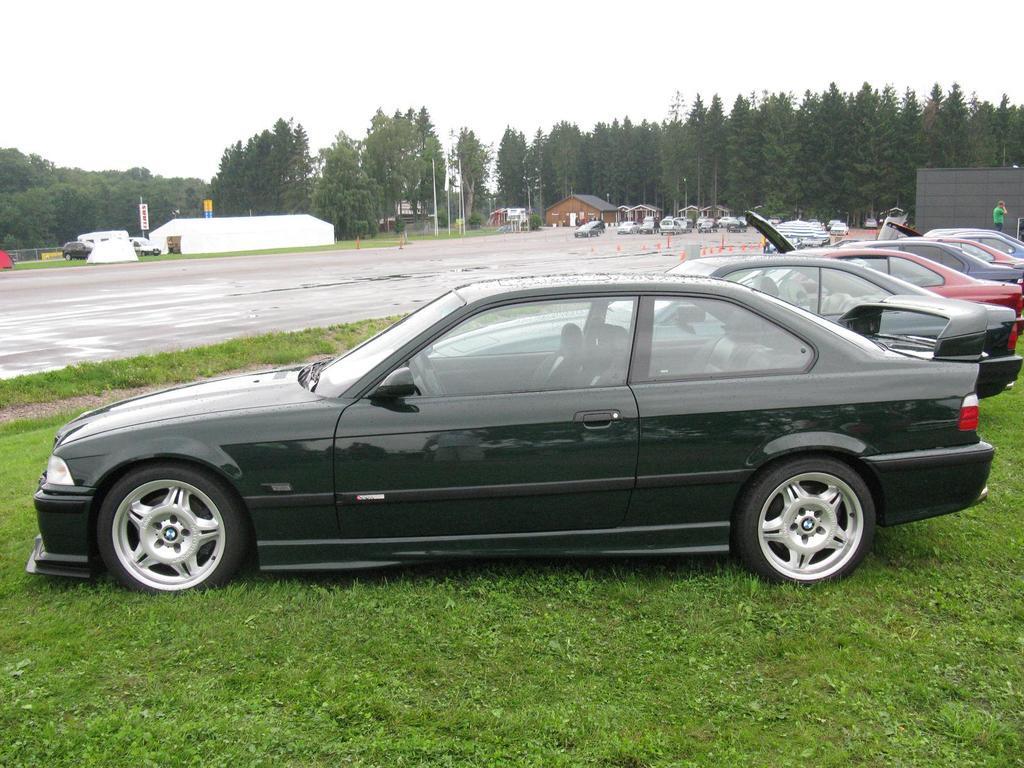Describe this image in one or two sentences. In this picture we can see vehicles, grass, road and wall. There is a person and we can see people's, houses, boards and trees. In the background of the image we can see the sky. 